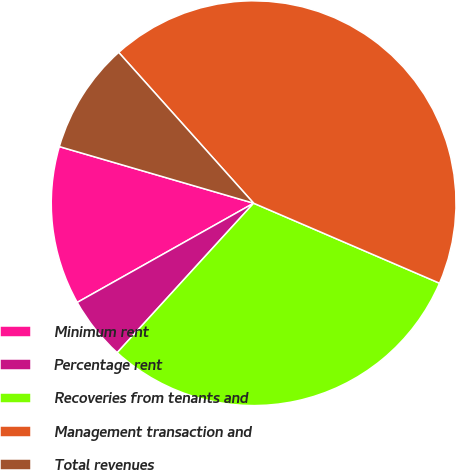<chart> <loc_0><loc_0><loc_500><loc_500><pie_chart><fcel>Minimum rent<fcel>Percentage rent<fcel>Recoveries from tenants and<fcel>Management transaction and<fcel>Total revenues<nl><fcel>12.67%<fcel>5.07%<fcel>30.31%<fcel>43.09%<fcel>8.87%<nl></chart> 